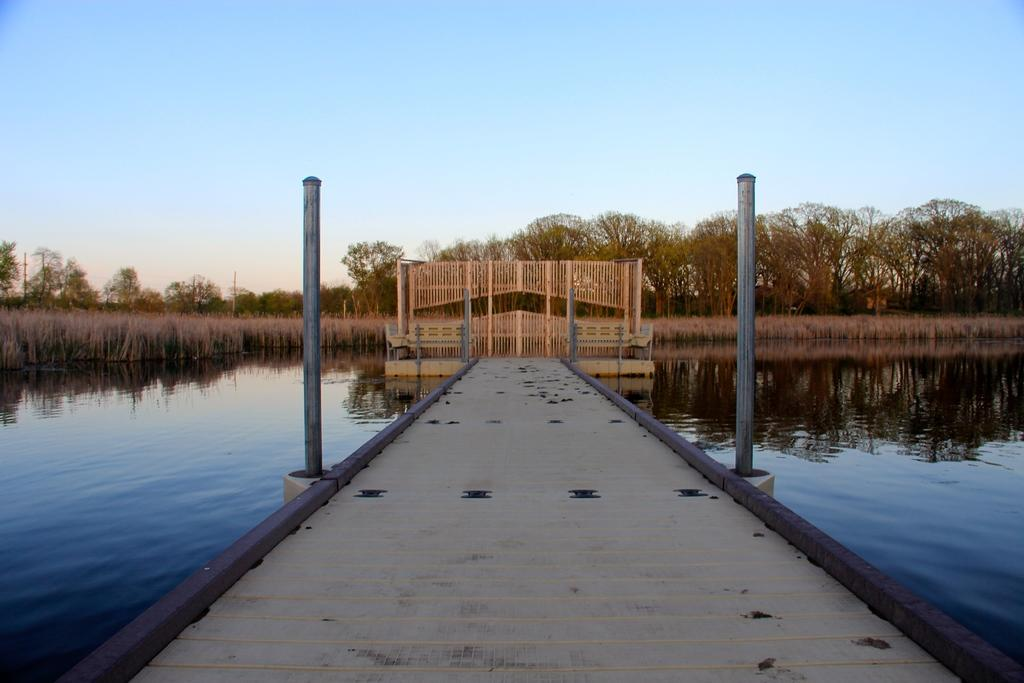What is the main structure in the center of the image? There is a bridge in the center of the image. What other objects can be seen in the image? There are poles in the image. What can be seen in the background of the image? There are trees and a fence in the background of the image. What is visible on both sides of the bridge? Water is visible on both sides of the bridge. What type of crime is being committed near the bridge in the image? There is no indication of any crime being committed in the image; it only shows a bridge, poles, trees, a fence, and water. How many hydrants are visible in the image? There are no hydrants present in the image. 